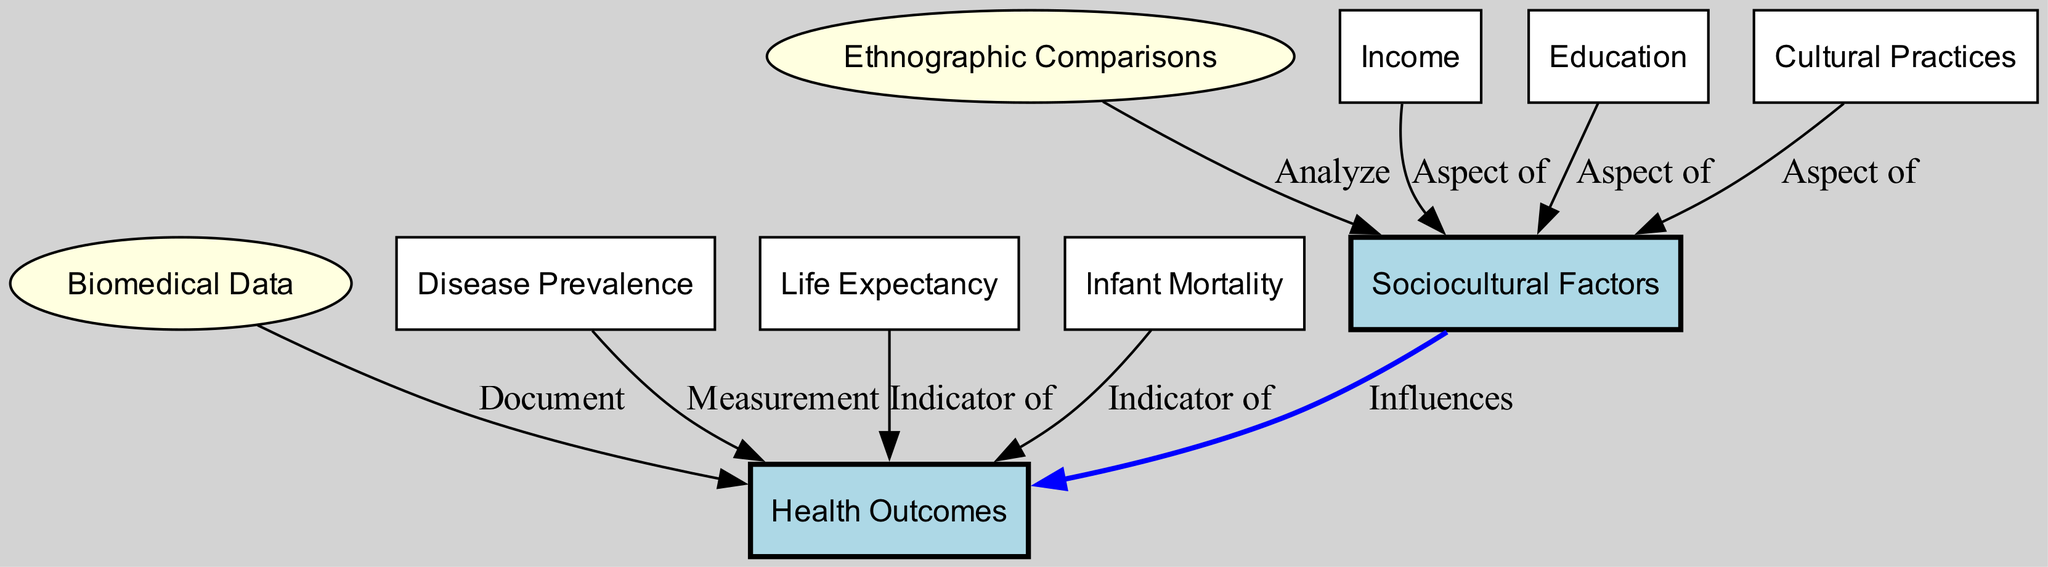What are the main nodes depicted in the diagram? The diagram showcases four main nodes: sociocultural factors, health outcomes, ethnographic comparisons, and biomedical data. These nodes represent the fundamental concepts and areas of focus in the diagram.
Answer: Sociocultural factors, health outcomes, ethnographic comparisons, biomedical data How many edges are present in the diagram? Upon investigation, the diagram contains a total of eight edges that depict relationships between the nodes, indicating various influences and indicators.
Answer: Eight What does the 'sociocultural factors' node influence? The edge leading from the 'sociocultural factors' node to the 'health outcomes' node indicates that sociocultural factors influence health outcomes. This relationship captures the core focus of this diagram.
Answer: Health outcomes What is an example of a factor that is an 'Aspect of' sociocultural factors? The diagram specifies three factors as aspects of sociocultural factors: income, education, and cultural practices. Each of these factors contributes to the broader category of sociocultural influences on health.
Answer: Income What kind of comparisons does the 'ethnographic comparisons' node perform? The 'ethnographic comparisons' node analyzes sociocultural factors, indicating that this node is focused on examining the social and cultural aspects that affect health.
Answer: Analyze How are health outcomes documented according to the diagram? The edge from the 'biomedical data' node to the 'health outcomes' node indicates that biomedical data serves to document health outcomes, emphasizing the role of empirical data in understanding health issues.
Answer: Document Which indicators relate to health outcomes? The diagram shows life expectancy and infant mortality as indicators of health outcomes, demonstrating the importance of these metrics in assessing overall health status.
Answer: Life expectancy, infant mortality What is the relationship between disease prevalence and health outcomes? The connection from the 'disease prevalence' node to the 'health outcomes' node indicates that disease prevalence is measured in relation to health outcomes, showcasing how this metric informs health analysis.
Answer: Measurement In what context are cultural practices viewed in the diagram? The 'cultural practices' node is categorized as an aspect of sociocultural factors, illustrating its role within the broader sociocultural framework that affects health outcomes.
Answer: Aspect of 